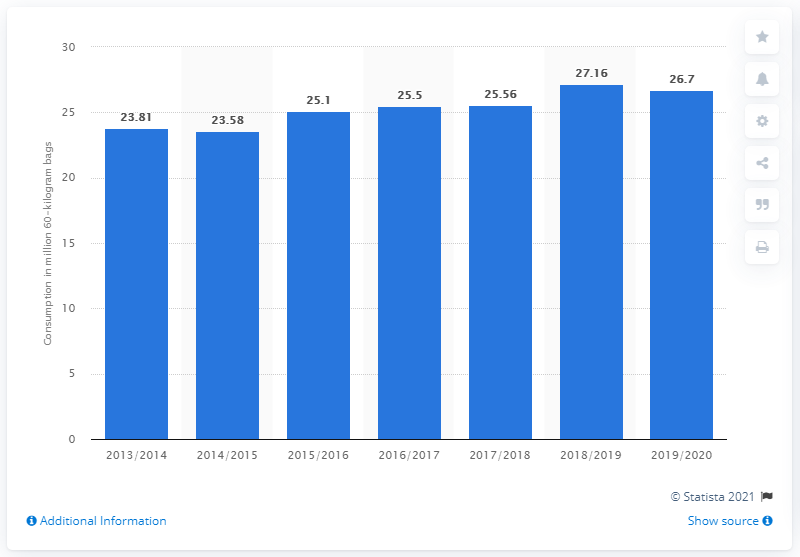Identify some key points in this picture. In the previous fiscal year, the total amount of coffee consumed by the United States was 25.56... In the 2018/2019 fiscal year, the United States consumed 27.16 metric tons of 60-kilogram bags of coffee. 